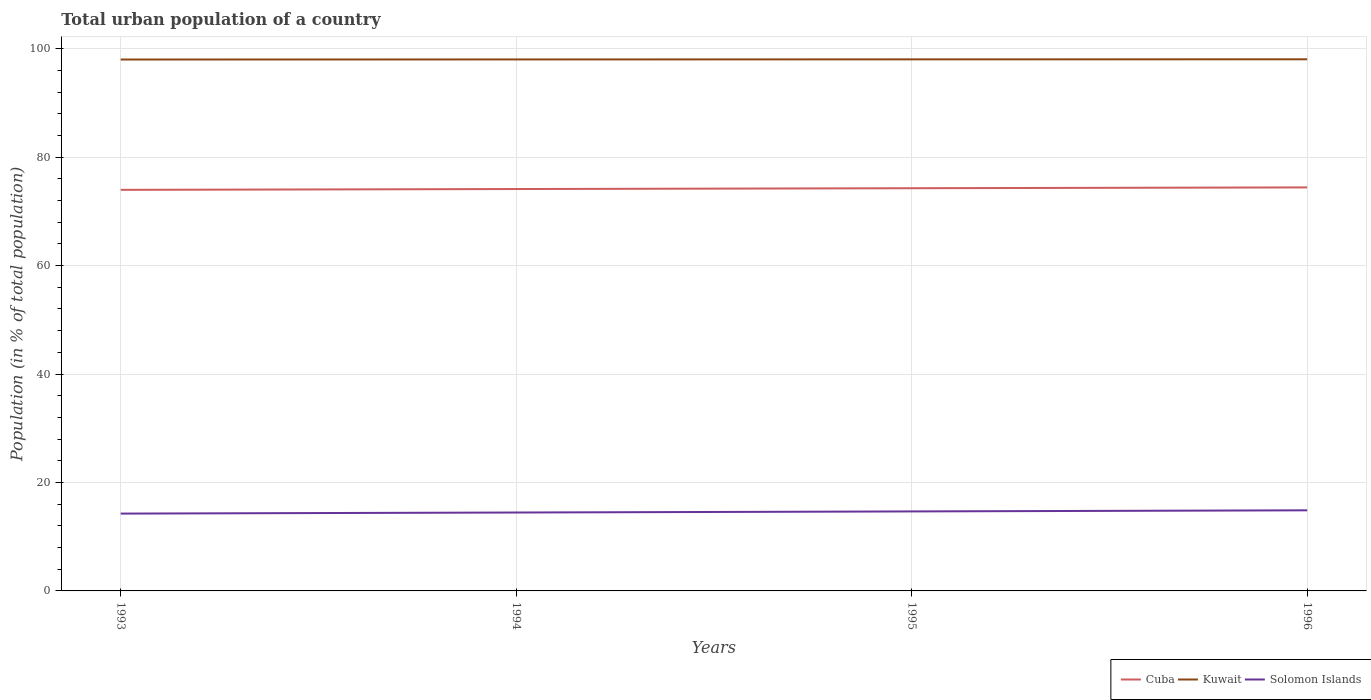How many different coloured lines are there?
Ensure brevity in your answer.  3. Does the line corresponding to Solomon Islands intersect with the line corresponding to Kuwait?
Offer a very short reply. No. Is the number of lines equal to the number of legend labels?
Offer a terse response. Yes. Across all years, what is the maximum urban population in Kuwait?
Ensure brevity in your answer.  98.02. In which year was the urban population in Cuba maximum?
Make the answer very short. 1993. What is the total urban population in Cuba in the graph?
Ensure brevity in your answer.  -0.15. What is the difference between the highest and the second highest urban population in Cuba?
Give a very brief answer. 0.45. What is the difference between the highest and the lowest urban population in Cuba?
Your response must be concise. 2. How many lines are there?
Ensure brevity in your answer.  3. What is the difference between two consecutive major ticks on the Y-axis?
Your answer should be compact. 20. Does the graph contain grids?
Make the answer very short. Yes. What is the title of the graph?
Keep it short and to the point. Total urban population of a country. What is the label or title of the Y-axis?
Ensure brevity in your answer.  Population (in % of total population). What is the Population (in % of total population) of Cuba in 1993?
Provide a short and direct response. 73.98. What is the Population (in % of total population) in Kuwait in 1993?
Give a very brief answer. 98.02. What is the Population (in % of total population) of Solomon Islands in 1993?
Offer a very short reply. 14.26. What is the Population (in % of total population) in Cuba in 1994?
Offer a terse response. 74.13. What is the Population (in % of total population) of Kuwait in 1994?
Keep it short and to the point. 98.03. What is the Population (in % of total population) of Solomon Islands in 1994?
Make the answer very short. 14.46. What is the Population (in % of total population) of Cuba in 1995?
Give a very brief answer. 74.28. What is the Population (in % of total population) in Kuwait in 1995?
Provide a short and direct response. 98.04. What is the Population (in % of total population) of Solomon Islands in 1995?
Your answer should be compact. 14.66. What is the Population (in % of total population) of Cuba in 1996?
Keep it short and to the point. 74.43. What is the Population (in % of total population) in Kuwait in 1996?
Ensure brevity in your answer.  98.06. What is the Population (in % of total population) in Solomon Islands in 1996?
Offer a terse response. 14.87. Across all years, what is the maximum Population (in % of total population) in Cuba?
Give a very brief answer. 74.43. Across all years, what is the maximum Population (in % of total population) in Kuwait?
Your answer should be compact. 98.06. Across all years, what is the maximum Population (in % of total population) in Solomon Islands?
Make the answer very short. 14.87. Across all years, what is the minimum Population (in % of total population) of Cuba?
Make the answer very short. 73.98. Across all years, what is the minimum Population (in % of total population) in Kuwait?
Keep it short and to the point. 98.02. Across all years, what is the minimum Population (in % of total population) of Solomon Islands?
Provide a succinct answer. 14.26. What is the total Population (in % of total population) in Cuba in the graph?
Offer a terse response. 296.81. What is the total Population (in % of total population) in Kuwait in the graph?
Provide a short and direct response. 392.14. What is the total Population (in % of total population) in Solomon Islands in the graph?
Give a very brief answer. 58.26. What is the difference between the Population (in % of total population) of Kuwait in 1993 and that in 1994?
Provide a short and direct response. -0.01. What is the difference between the Population (in % of total population) in Kuwait in 1993 and that in 1995?
Make the answer very short. -0.03. What is the difference between the Population (in % of total population) of Solomon Islands in 1993 and that in 1995?
Make the answer very short. -0.4. What is the difference between the Population (in % of total population) of Cuba in 1993 and that in 1996?
Make the answer very short. -0.45. What is the difference between the Population (in % of total population) of Kuwait in 1993 and that in 1996?
Your answer should be very brief. -0.04. What is the difference between the Population (in % of total population) in Solomon Islands in 1993 and that in 1996?
Ensure brevity in your answer.  -0.61. What is the difference between the Population (in % of total population) of Cuba in 1994 and that in 1995?
Make the answer very short. -0.15. What is the difference between the Population (in % of total population) of Kuwait in 1994 and that in 1995?
Make the answer very short. -0.01. What is the difference between the Population (in % of total population) in Solomon Islands in 1994 and that in 1995?
Offer a terse response. -0.2. What is the difference between the Population (in % of total population) in Cuba in 1994 and that in 1996?
Provide a short and direct response. -0.3. What is the difference between the Population (in % of total population) in Kuwait in 1994 and that in 1996?
Your answer should be compact. -0.03. What is the difference between the Population (in % of total population) in Solomon Islands in 1994 and that in 1996?
Give a very brief answer. -0.41. What is the difference between the Population (in % of total population) of Cuba in 1995 and that in 1996?
Your answer should be compact. -0.15. What is the difference between the Population (in % of total population) in Kuwait in 1995 and that in 1996?
Your answer should be very brief. -0.01. What is the difference between the Population (in % of total population) in Solomon Islands in 1995 and that in 1996?
Provide a succinct answer. -0.2. What is the difference between the Population (in % of total population) in Cuba in 1993 and the Population (in % of total population) in Kuwait in 1994?
Ensure brevity in your answer.  -24.05. What is the difference between the Population (in % of total population) of Cuba in 1993 and the Population (in % of total population) of Solomon Islands in 1994?
Your answer should be compact. 59.52. What is the difference between the Population (in % of total population) in Kuwait in 1993 and the Population (in % of total population) in Solomon Islands in 1994?
Your response must be concise. 83.55. What is the difference between the Population (in % of total population) of Cuba in 1993 and the Population (in % of total population) of Kuwait in 1995?
Make the answer very short. -24.07. What is the difference between the Population (in % of total population) in Cuba in 1993 and the Population (in % of total population) in Solomon Islands in 1995?
Give a very brief answer. 59.31. What is the difference between the Population (in % of total population) in Kuwait in 1993 and the Population (in % of total population) in Solomon Islands in 1995?
Keep it short and to the point. 83.35. What is the difference between the Population (in % of total population) of Cuba in 1993 and the Population (in % of total population) of Kuwait in 1996?
Offer a terse response. -24.08. What is the difference between the Population (in % of total population) of Cuba in 1993 and the Population (in % of total population) of Solomon Islands in 1996?
Give a very brief answer. 59.11. What is the difference between the Population (in % of total population) in Kuwait in 1993 and the Population (in % of total population) in Solomon Islands in 1996?
Give a very brief answer. 83.15. What is the difference between the Population (in % of total population) in Cuba in 1994 and the Population (in % of total population) in Kuwait in 1995?
Your answer should be compact. -23.92. What is the difference between the Population (in % of total population) in Cuba in 1994 and the Population (in % of total population) in Solomon Islands in 1995?
Give a very brief answer. 59.46. What is the difference between the Population (in % of total population) of Kuwait in 1994 and the Population (in % of total population) of Solomon Islands in 1995?
Ensure brevity in your answer.  83.36. What is the difference between the Population (in % of total population) in Cuba in 1994 and the Population (in % of total population) in Kuwait in 1996?
Your answer should be very brief. -23.93. What is the difference between the Population (in % of total population) in Cuba in 1994 and the Population (in % of total population) in Solomon Islands in 1996?
Give a very brief answer. 59.26. What is the difference between the Population (in % of total population) of Kuwait in 1994 and the Population (in % of total population) of Solomon Islands in 1996?
Provide a short and direct response. 83.16. What is the difference between the Population (in % of total population) of Cuba in 1995 and the Population (in % of total population) of Kuwait in 1996?
Offer a terse response. -23.78. What is the difference between the Population (in % of total population) of Cuba in 1995 and the Population (in % of total population) of Solomon Islands in 1996?
Provide a succinct answer. 59.41. What is the difference between the Population (in % of total population) in Kuwait in 1995 and the Population (in % of total population) in Solomon Islands in 1996?
Provide a succinct answer. 83.17. What is the average Population (in % of total population) in Cuba per year?
Ensure brevity in your answer.  74.2. What is the average Population (in % of total population) in Kuwait per year?
Provide a succinct answer. 98.04. What is the average Population (in % of total population) of Solomon Islands per year?
Give a very brief answer. 14.56. In the year 1993, what is the difference between the Population (in % of total population) of Cuba and Population (in % of total population) of Kuwait?
Your response must be concise. -24.04. In the year 1993, what is the difference between the Population (in % of total population) of Cuba and Population (in % of total population) of Solomon Islands?
Make the answer very short. 59.72. In the year 1993, what is the difference between the Population (in % of total population) in Kuwait and Population (in % of total population) in Solomon Islands?
Keep it short and to the point. 83.75. In the year 1994, what is the difference between the Population (in % of total population) in Cuba and Population (in % of total population) in Kuwait?
Your answer should be compact. -23.9. In the year 1994, what is the difference between the Population (in % of total population) in Cuba and Population (in % of total population) in Solomon Islands?
Make the answer very short. 59.66. In the year 1994, what is the difference between the Population (in % of total population) of Kuwait and Population (in % of total population) of Solomon Islands?
Ensure brevity in your answer.  83.57. In the year 1995, what is the difference between the Population (in % of total population) in Cuba and Population (in % of total population) in Kuwait?
Keep it short and to the point. -23.77. In the year 1995, what is the difference between the Population (in % of total population) of Cuba and Population (in % of total population) of Solomon Islands?
Give a very brief answer. 59.61. In the year 1995, what is the difference between the Population (in % of total population) of Kuwait and Population (in % of total population) of Solomon Islands?
Your answer should be very brief. 83.38. In the year 1996, what is the difference between the Population (in % of total population) of Cuba and Population (in % of total population) of Kuwait?
Give a very brief answer. -23.63. In the year 1996, what is the difference between the Population (in % of total population) in Cuba and Population (in % of total population) in Solomon Islands?
Ensure brevity in your answer.  59.56. In the year 1996, what is the difference between the Population (in % of total population) in Kuwait and Population (in % of total population) in Solomon Islands?
Keep it short and to the point. 83.19. What is the ratio of the Population (in % of total population) in Cuba in 1993 to that in 1994?
Your answer should be very brief. 1. What is the ratio of the Population (in % of total population) in Kuwait in 1993 to that in 1994?
Provide a succinct answer. 1. What is the ratio of the Population (in % of total population) of Solomon Islands in 1993 to that in 1994?
Ensure brevity in your answer.  0.99. What is the ratio of the Population (in % of total population) of Solomon Islands in 1993 to that in 1995?
Give a very brief answer. 0.97. What is the ratio of the Population (in % of total population) of Solomon Islands in 1993 to that in 1996?
Provide a short and direct response. 0.96. What is the ratio of the Population (in % of total population) of Solomon Islands in 1994 to that in 1995?
Keep it short and to the point. 0.99. What is the ratio of the Population (in % of total population) of Cuba in 1994 to that in 1996?
Ensure brevity in your answer.  1. What is the ratio of the Population (in % of total population) of Solomon Islands in 1994 to that in 1996?
Your answer should be very brief. 0.97. What is the ratio of the Population (in % of total population) in Cuba in 1995 to that in 1996?
Offer a very short reply. 1. What is the ratio of the Population (in % of total population) in Kuwait in 1995 to that in 1996?
Make the answer very short. 1. What is the ratio of the Population (in % of total population) of Solomon Islands in 1995 to that in 1996?
Keep it short and to the point. 0.99. What is the difference between the highest and the second highest Population (in % of total population) of Cuba?
Your response must be concise. 0.15. What is the difference between the highest and the second highest Population (in % of total population) in Kuwait?
Provide a succinct answer. 0.01. What is the difference between the highest and the second highest Population (in % of total population) of Solomon Islands?
Provide a succinct answer. 0.2. What is the difference between the highest and the lowest Population (in % of total population) in Cuba?
Your answer should be very brief. 0.45. What is the difference between the highest and the lowest Population (in % of total population) of Kuwait?
Your response must be concise. 0.04. What is the difference between the highest and the lowest Population (in % of total population) of Solomon Islands?
Your response must be concise. 0.61. 